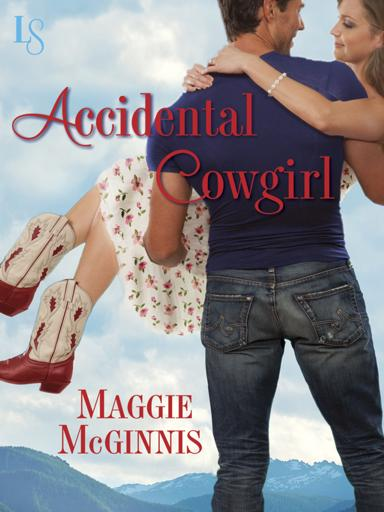How do the clothing choices of the individuals contribute to the theme of the book cover? The clothing of the individuals significantly contributes to the rustic, country theme. The man's denim attire and the woman's floral dress paired with cowboy boots allude to a cowboy or western lifestyle, which is in harmony with the title 'Accidental Cowgirl.' These choices help set the tone and context, inviting readers into a romantic rural story. 